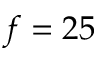<formula> <loc_0><loc_0><loc_500><loc_500>f = 2 5</formula> 